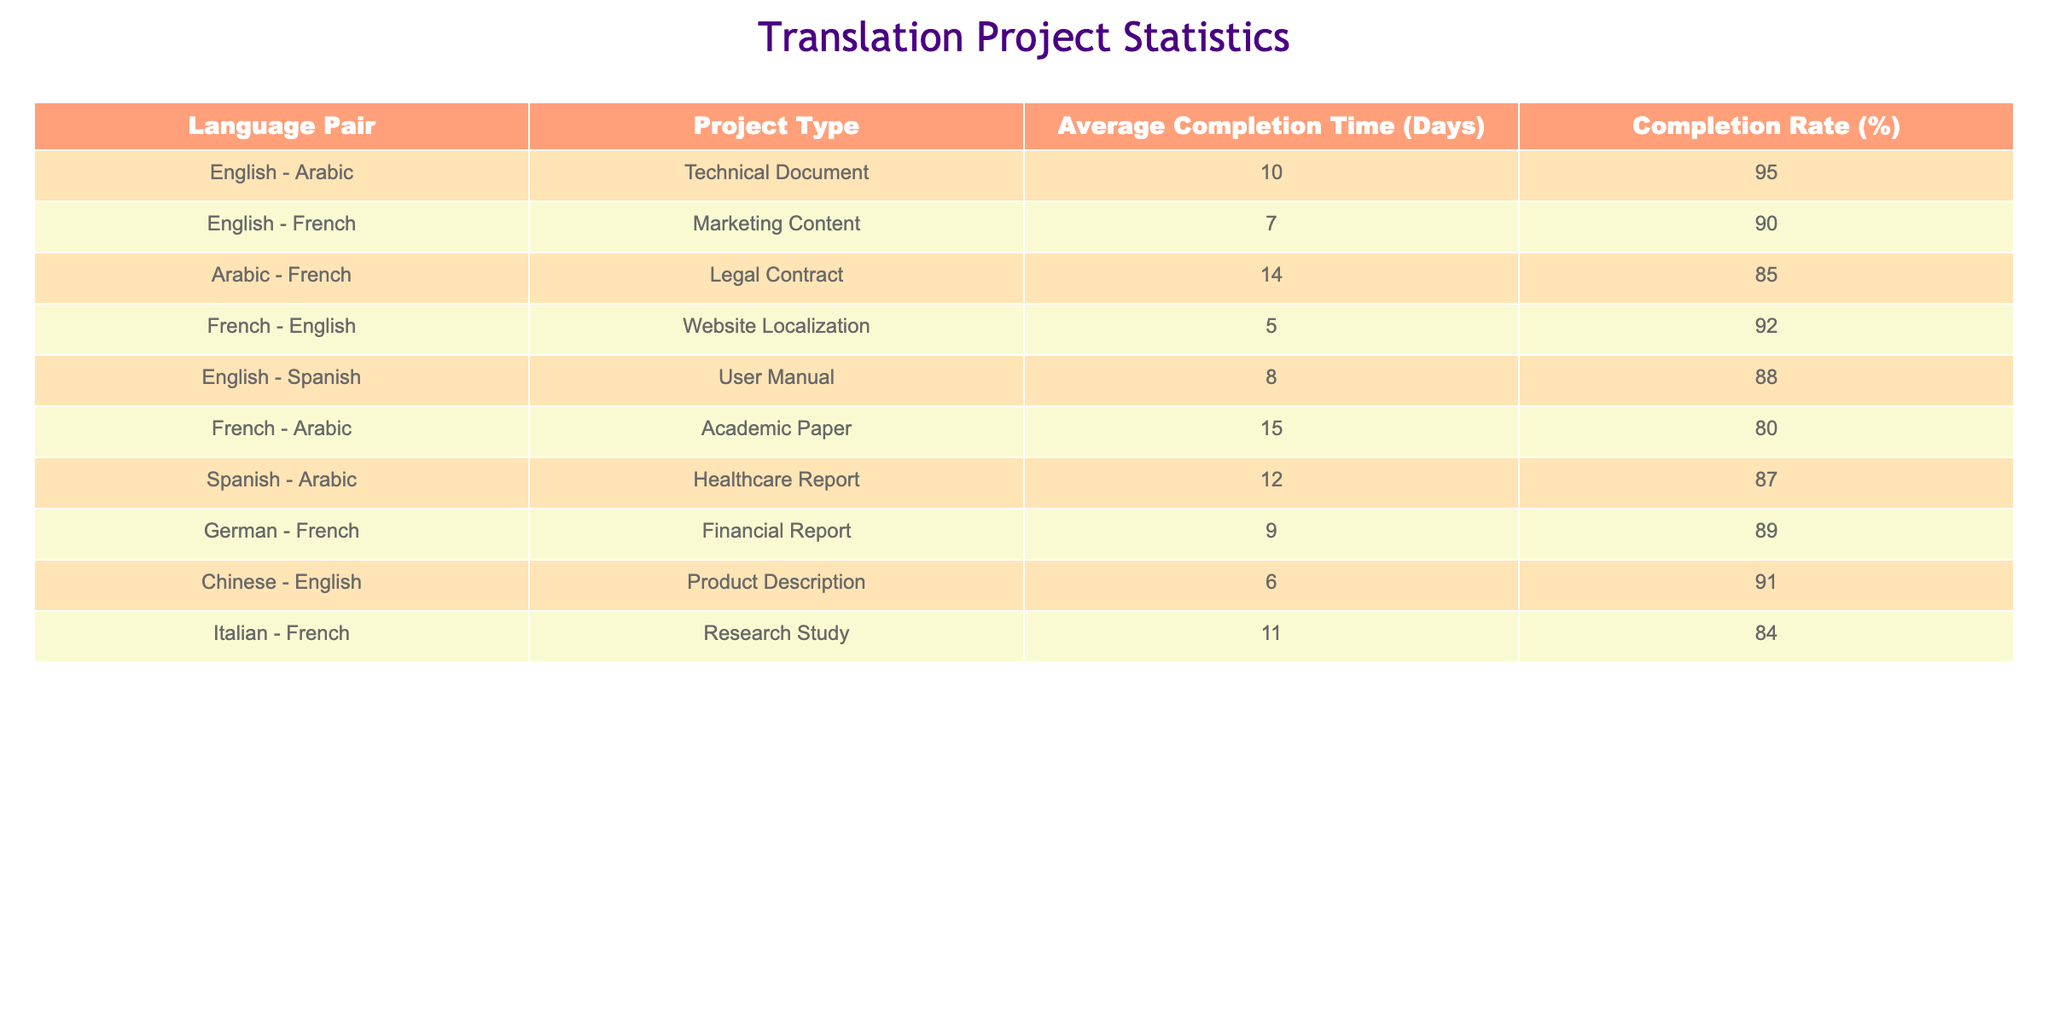What is the project type with the longest average completion time? The longest average completion time is 15 days, which corresponds to the project type 'Academic Paper' for the language pair 'French - Arabic'.
Answer: Academic Paper Which language pair has the highest completion rate? The highest completion rate is 95%, which is for the language pair 'English - Arabic' in the project type 'Technical Document'.
Answer: English - Arabic What is the average completion time for the projects involving Arabic? The completion times for projects involving Arabic are 10 days (English - Arabic), 14 days (Arabic - French), 15 days (French - Arabic), and 12 days (Spanish - Arabic). To find the average, we sum the values (10 + 14 + 15 + 12) = 51 days and divide by the number of projects (4), which gives us 51/4 = 12.75 days.
Answer: 12.75 days Is the completion rate for the 'User Manual' project higher than 85%? The completion rate for the project type 'User Manual' (English - Spanish) is 88%, which is indeed higher than 85%.
Answer: Yes What are the average completion times for the projects with a completion rate less than 85%? The only project with a completion rate below 85% is 'Academic Paper' (French - Arabic) at 15 days and 'Legal Contract' (Arabic - French) at 14 days. To find the average, we sum them (15 + 14) = 29 days and divide by 2, resulting in an average of 29/2 = 14.5 days.
Answer: 14.5 days 